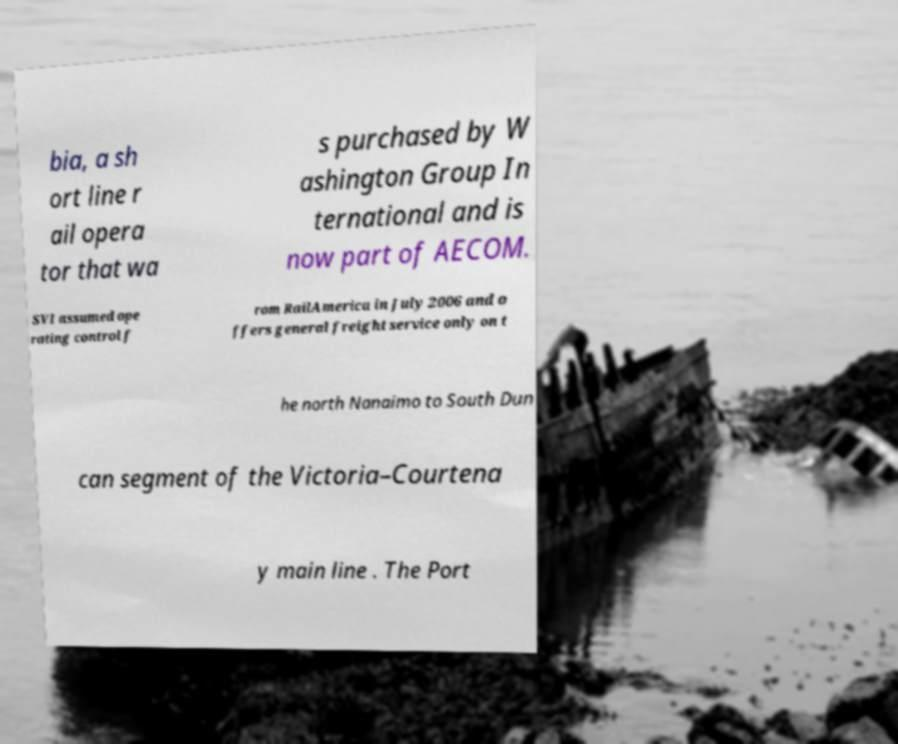What messages or text are displayed in this image? I need them in a readable, typed format. bia, a sh ort line r ail opera tor that wa s purchased by W ashington Group In ternational and is now part of AECOM. SVI assumed ope rating control f rom RailAmerica in July 2006 and o ffers general freight service only on t he north Nanaimo to South Dun can segment of the Victoria–Courtena y main line . The Port 